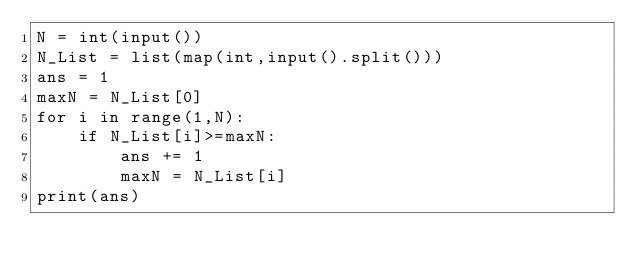Convert code to text. <code><loc_0><loc_0><loc_500><loc_500><_Python_>N = int(input())
N_List = list(map(int,input().split()))
ans = 1
maxN = N_List[0]
for i in range(1,N):
    if N_List[i]>=maxN:
        ans += 1
        maxN = N_List[i]
print(ans)</code> 